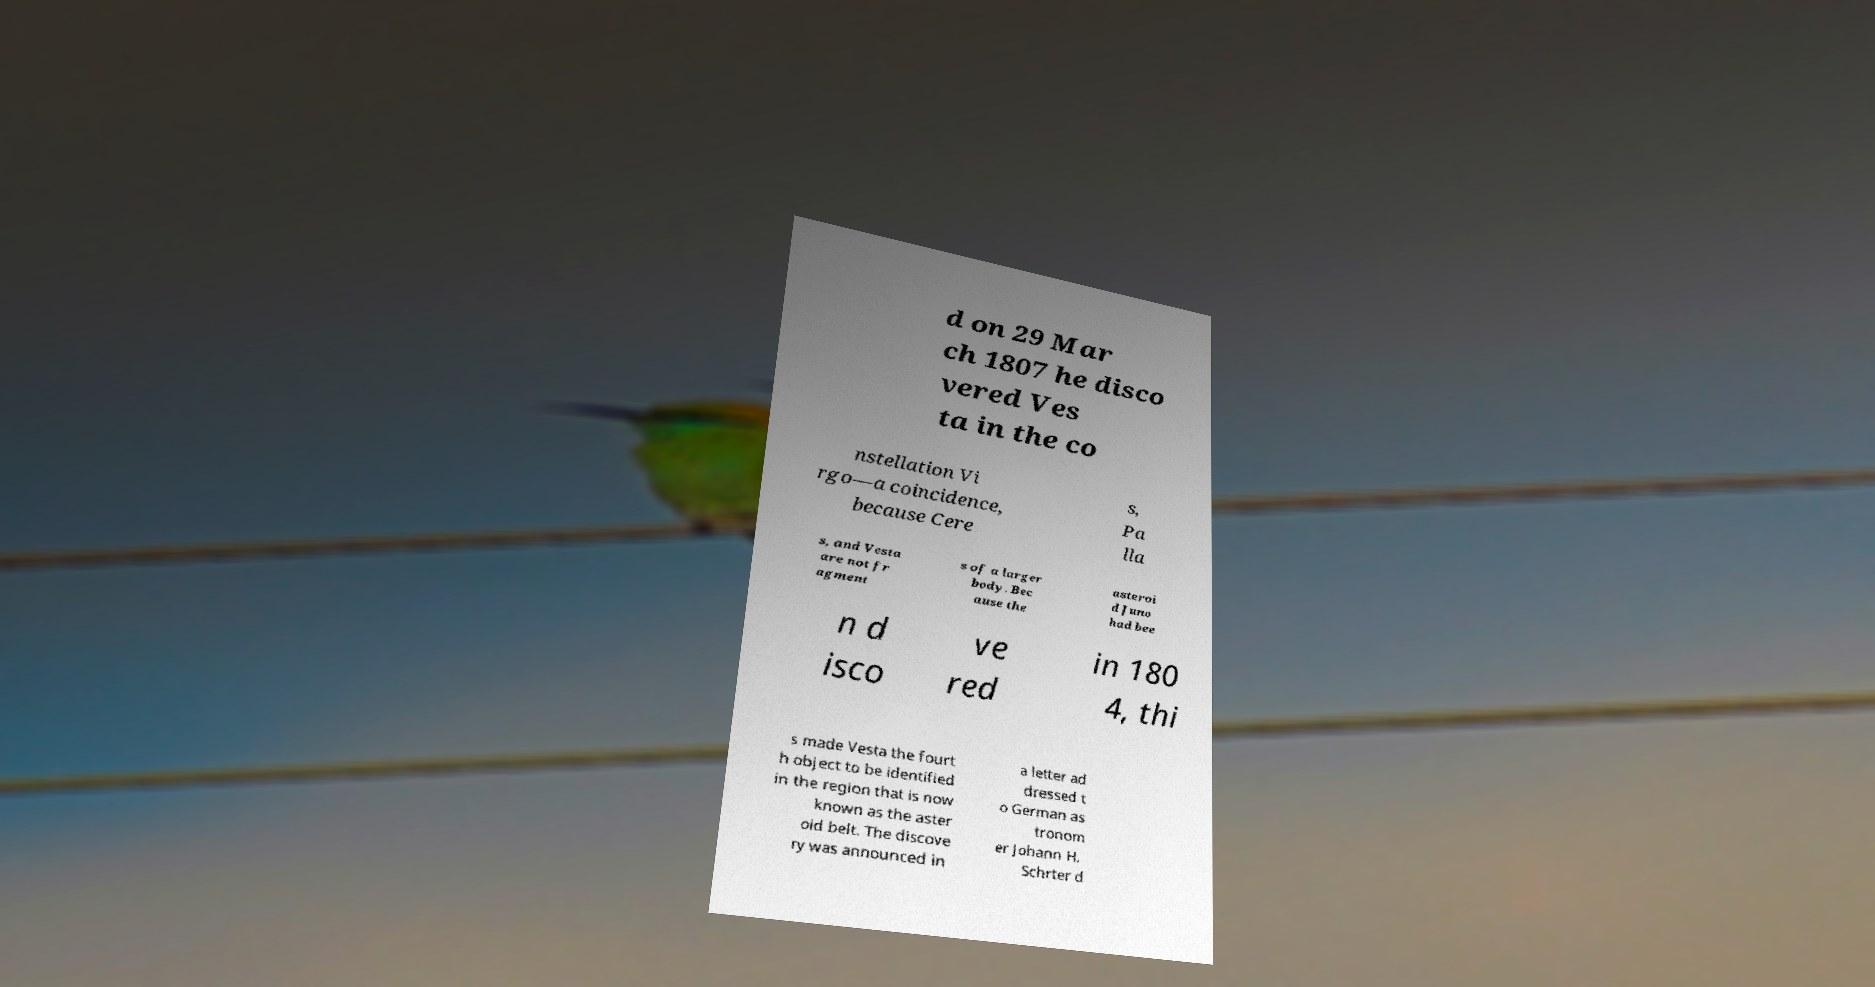What messages or text are displayed in this image? I need them in a readable, typed format. d on 29 Mar ch 1807 he disco vered Ves ta in the co nstellation Vi rgo—a coincidence, because Cere s, Pa lla s, and Vesta are not fr agment s of a larger body. Bec ause the asteroi d Juno had bee n d isco ve red in 180 4, thi s made Vesta the fourt h object to be identified in the region that is now known as the aster oid belt. The discove ry was announced in a letter ad dressed t o German as tronom er Johann H. Schrter d 